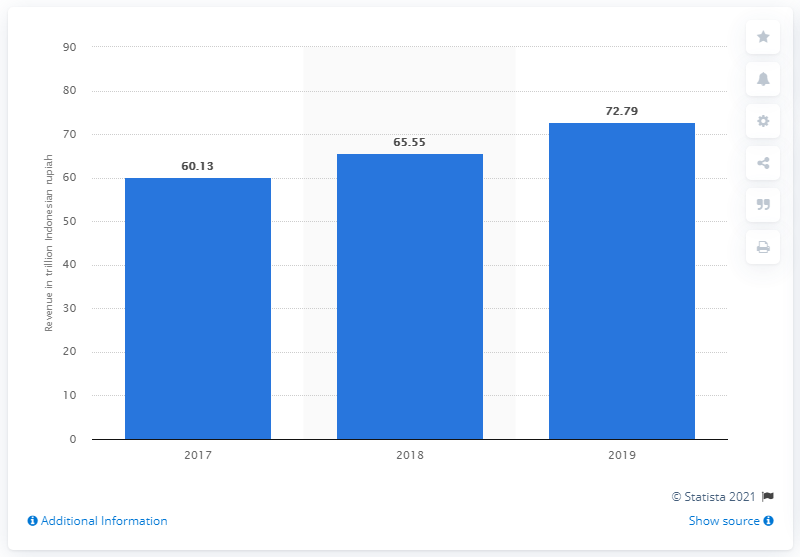Draw attention to some important aspects in this diagram. In 2019, the total revenue of PT Telkom Indonesia was Rp 72,790,000,000. 